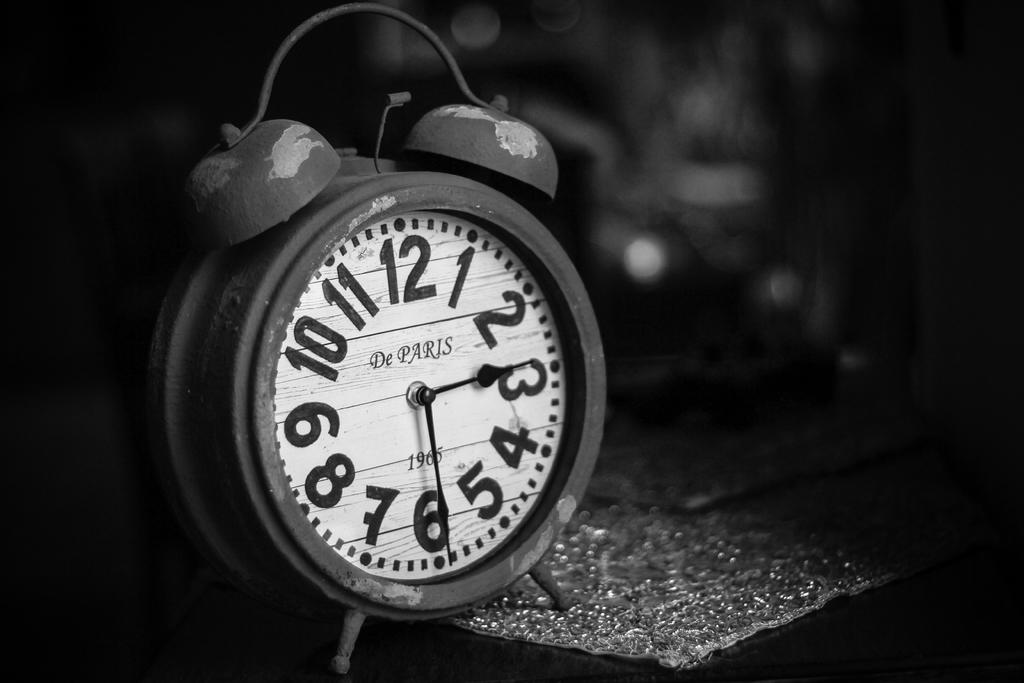<image>
Create a compact narrative representing the image presented. An alarm clock made in 1965 from the company De Paris. 